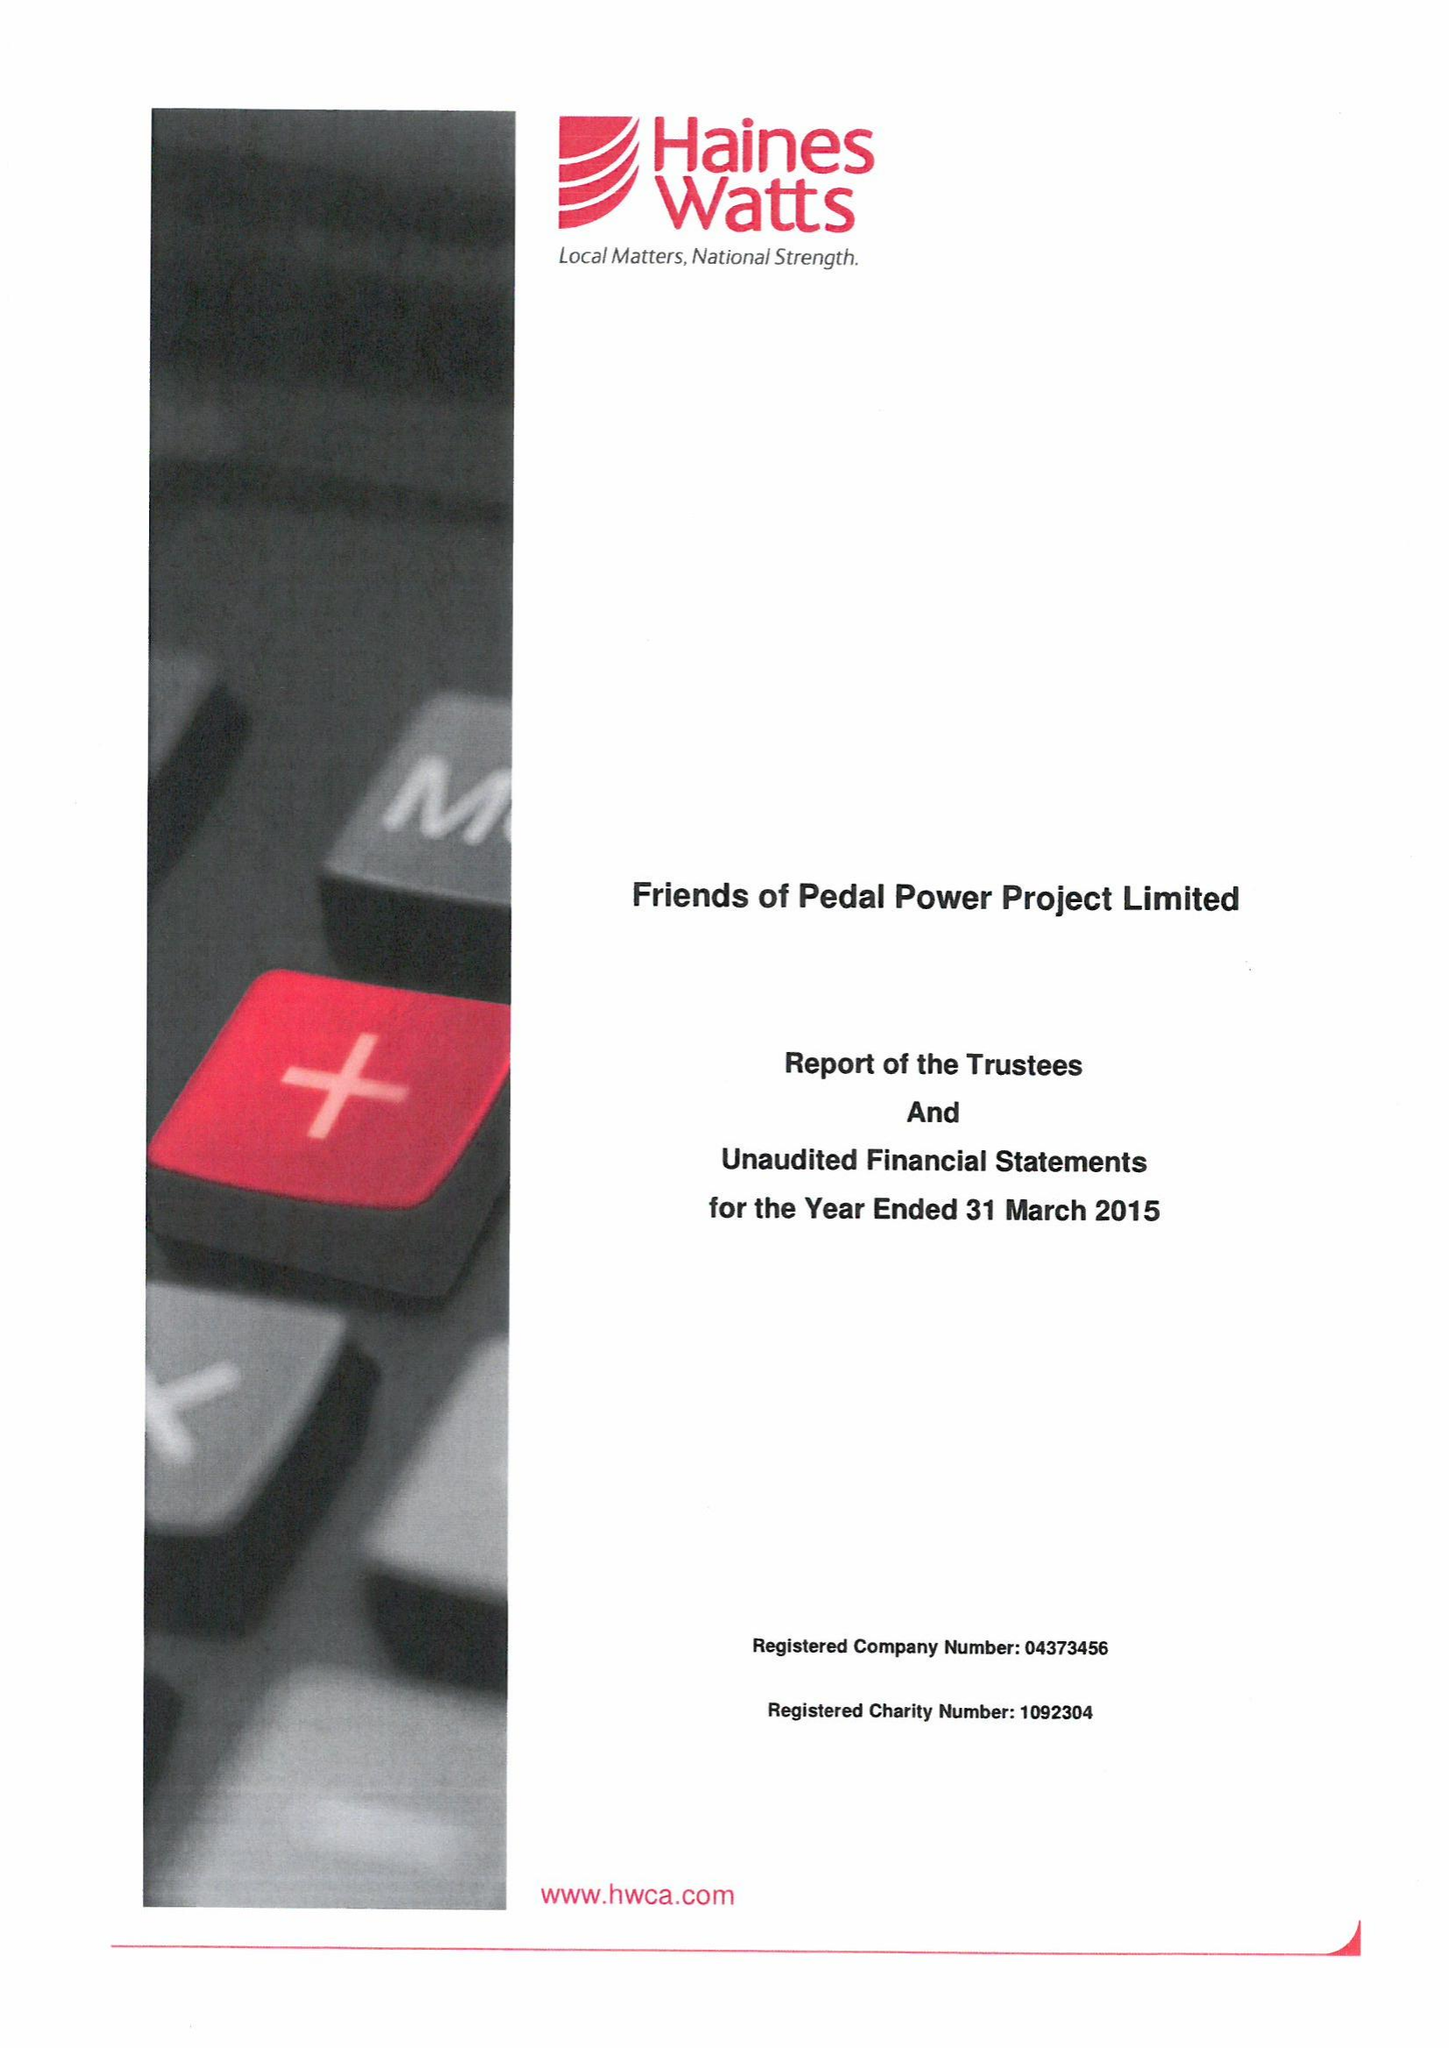What is the value for the address__post_town?
Answer the question using a single word or phrase. CARDIFF 